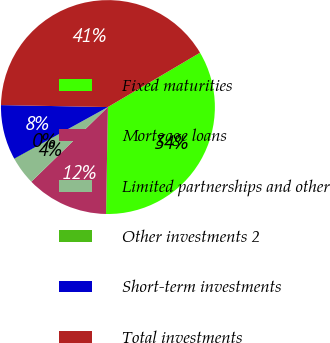Convert chart to OTSL. <chart><loc_0><loc_0><loc_500><loc_500><pie_chart><fcel>Fixed maturities<fcel>Mortgage loans<fcel>Limited partnerships and other<fcel>Other investments 2<fcel>Short-term investments<fcel>Total investments<nl><fcel>33.76%<fcel>12.42%<fcel>4.2%<fcel>0.08%<fcel>8.31%<fcel>41.22%<nl></chart> 